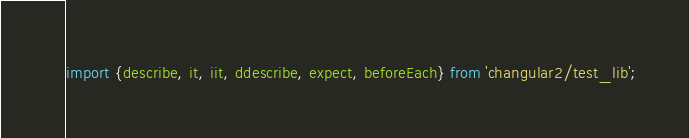Convert code to text. <code><loc_0><loc_0><loc_500><loc_500><_JavaScript_>import {describe, it, iit, ddescribe, expect, beforeEach} from 'changular2/test_lib';</code> 